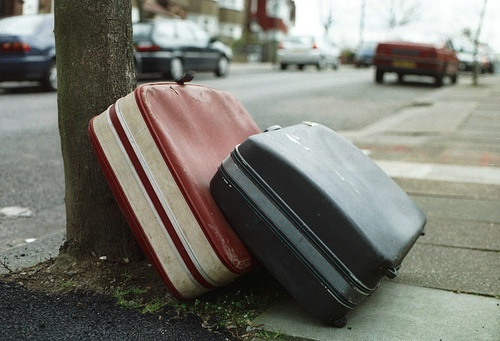Describe the objects in this image and their specific colors. I can see suitcase in black, darkgray, gray, and lightgray tones, car in black, lightgray, gray, and darkgray tones, car in black, white, maroon, and gray tones, car in black, lightgray, and gray tones, and car in black, lightgray, darkgray, and gray tones in this image. 